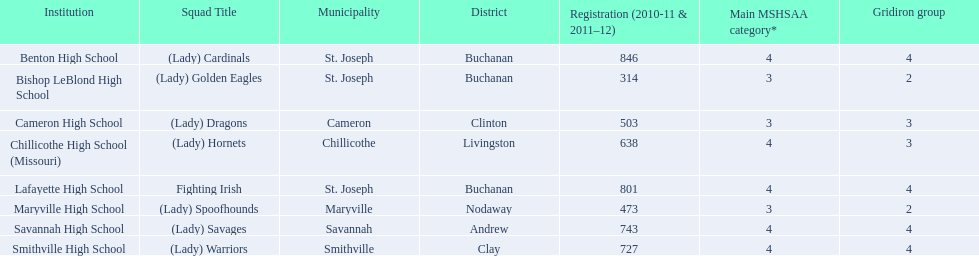How many of the schools had at least 500 students enrolled in the 2010-2011 and 2011-2012 season? 6. 